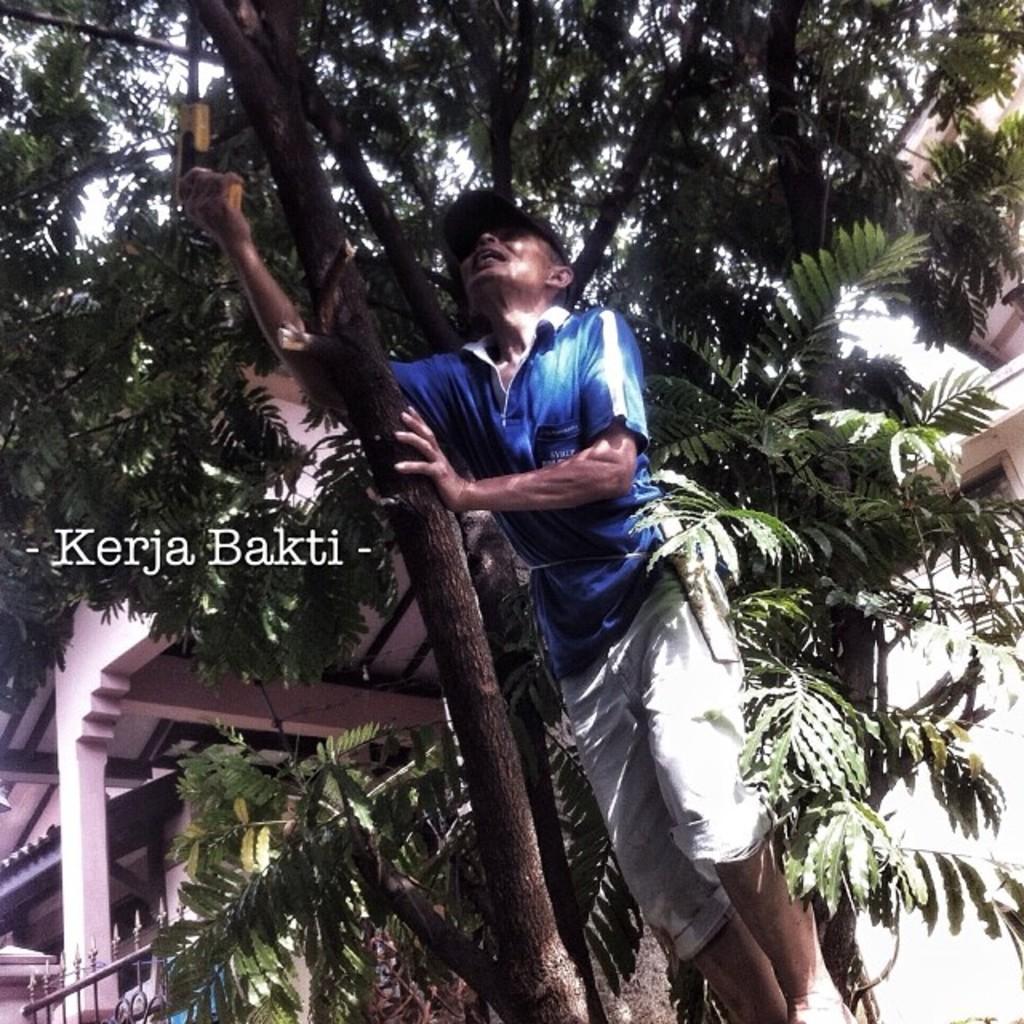Please provide a concise description of this image. In this picture I can see trees, buildings and I can see a man holding a tree branch and he is holding a instrument in his hand and I can see text on the left side of the picture. 